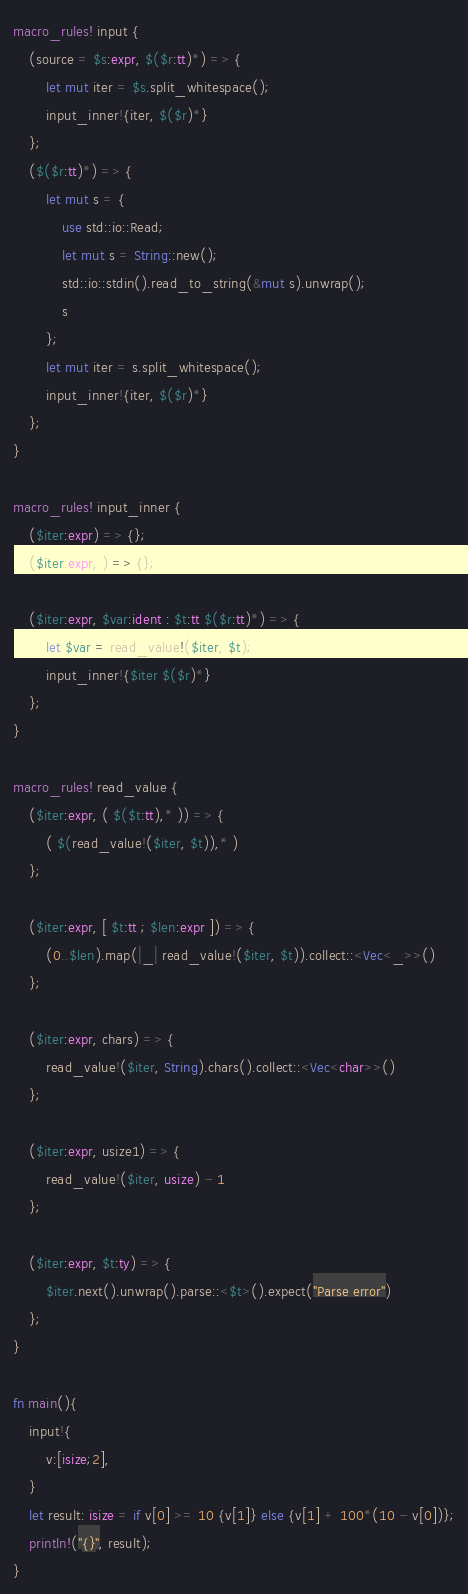<code> <loc_0><loc_0><loc_500><loc_500><_Rust_>macro_rules! input {
    (source = $s:expr, $($r:tt)*) => {
        let mut iter = $s.split_whitespace();
        input_inner!{iter, $($r)*}
    };
    ($($r:tt)*) => {
        let mut s = {
            use std::io::Read;
            let mut s = String::new();
            std::io::stdin().read_to_string(&mut s).unwrap();
            s
        };
        let mut iter = s.split_whitespace();
        input_inner!{iter, $($r)*}
    };
}

macro_rules! input_inner {
    ($iter:expr) => {};
    ($iter:expr, ) => {};

    ($iter:expr, $var:ident : $t:tt $($r:tt)*) => {
        let $var = read_value!($iter, $t);
        input_inner!{$iter $($r)*}
    };
}

macro_rules! read_value {
    ($iter:expr, ( $($t:tt),* )) => {
        ( $(read_value!($iter, $t)),* )
    };

    ($iter:expr, [ $t:tt ; $len:expr ]) => {
        (0..$len).map(|_| read_value!($iter, $t)).collect::<Vec<_>>()
    };

    ($iter:expr, chars) => {
        read_value!($iter, String).chars().collect::<Vec<char>>()
    };

    ($iter:expr, usize1) => {
        read_value!($iter, usize) - 1
    };

    ($iter:expr, $t:ty) => {
        $iter.next().unwrap().parse::<$t>().expect("Parse error")
    };
}

fn main(){
    input!{
        v:[isize;2],
    }
    let result: isize = if v[0] >= 10 {v[1]} else {v[1] + 100*(10 - v[0])};
    println!("{}", result);
}</code> 